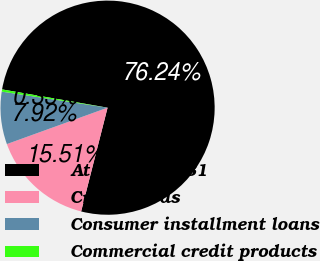Convert chart to OTSL. <chart><loc_0><loc_0><loc_500><loc_500><pie_chart><fcel>At December 31<fcel>Credit cards<fcel>Consumer installment loans<fcel>Commercial credit products<nl><fcel>76.25%<fcel>15.51%<fcel>7.92%<fcel>0.33%<nl></chart> 